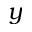Convert formula to latex. <formula><loc_0><loc_0><loc_500><loc_500>y</formula> 